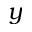Convert formula to latex. <formula><loc_0><loc_0><loc_500><loc_500>y</formula> 